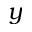Convert formula to latex. <formula><loc_0><loc_0><loc_500><loc_500>y</formula> 